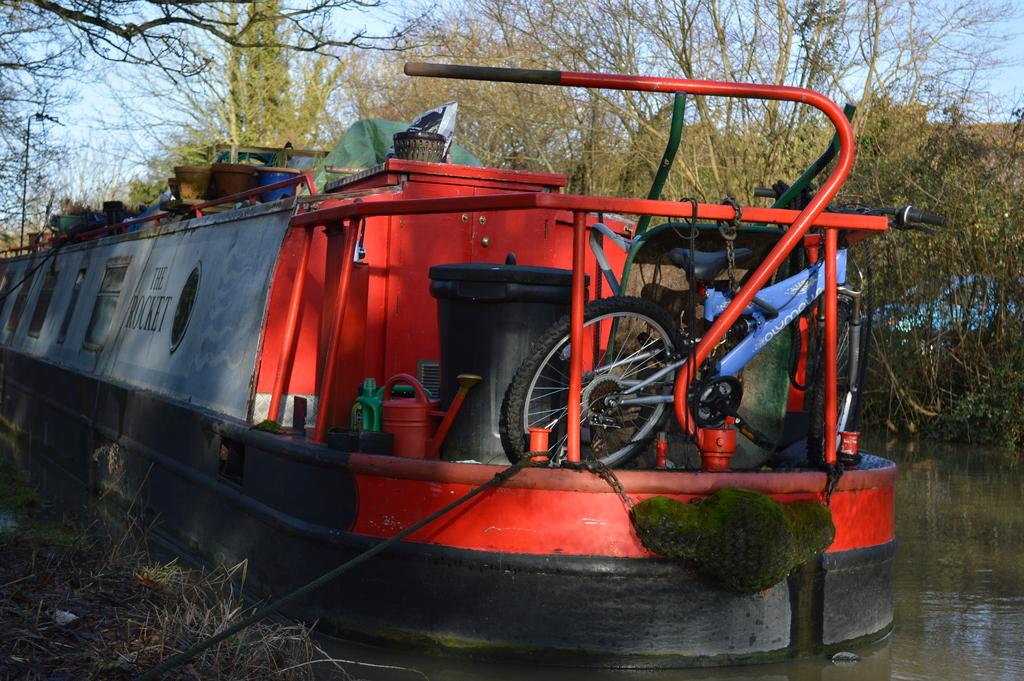What is the main subject of the image? The main subject of the image is a boat. Where is the boat located in the image? The boat is on the water surface. What type of natural environment is visible in the image? There are many trees visible in the image. Can you see a girl wearing stockings in the image? There is no girl or stockings present in the image. What type of tool, such as a spade, can be seen being used in the image? There is no tool, such as a spade, present or being used in the image. 